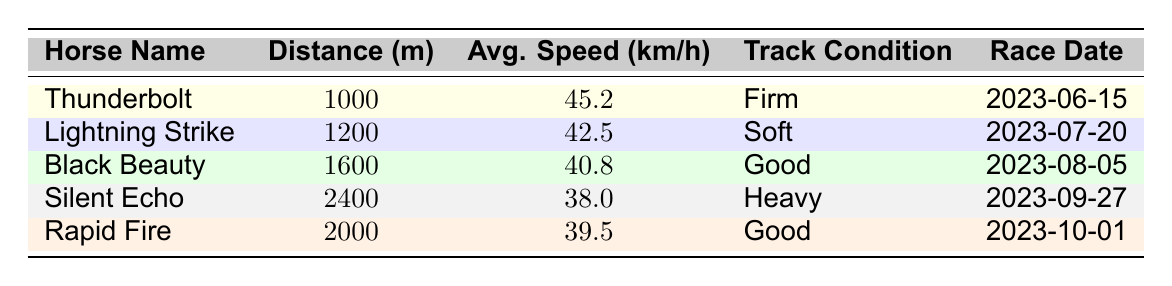What is the average speed of Thunderbolt? Looking at the table, the average speed of Thunderbolt is listed directly in the row under his name. It shows that his average speed is 45.2 km/h.
Answer: 45.2 km/h Which horse ran the longest distance and what was the average speed? The longest distance in the table is 2400 meters, which is associated with Silent Echo. The average speed for Silent Echo is displayed as 38.0 km/h.
Answer: Silent Echo, 38.0 km/h Is there a horse that ran on a heavy track? Yes, the table indicates that Silent Echo ran on a heavy track. This is evident from the track condition column where "Heavy" is specified for Silent Echo's entry.
Answer: Yes What is the difference in average speed between Lightning Strike and Rapid Fire? To find the difference, we need the average speeds: Lightning Strike has an average speed of 42.5 km/h, and Rapid Fire has 39.5 km/h. The difference is calculated as 42.5 - 39.5 = 3.0 km/h.
Answer: 3.0 km/h Which horse had the highest average speed and what is that speed? The highest average speed can be identified by comparing all average speeds in the table. Thunderbolt has the highest speed listed at 45.2 km/h.
Answer: Thunderbolt, 45.2 km/h What is the average speed of the horses that competed on good track conditions? There are two horses that ran on good track conditions: Black Beauty (40.8 km/h) and Rapid Fire (39.5 km/h). To find the average speed, we sum the speeds (40.8 + 39.5 = 80.3) and divide by 2, resulting in 80.3/2 = 40.15 km/h.
Answer: 40.15 km/h Did any horse run a distance of 2000 meters? Yes, Rapid Fire ran a distance of 2000 meters, as shown in the distance column of the corresponding row.
Answer: Yes What is the overall trend in average speed as the distance increases based on the data provided? By examining the average speeds alongside the distances, it can be noted that average speeds tend to decrease as the distances increase. For instance, Thunderbolt's speed (1000m) is the highest, and Silent Echo's (2400m) is the lowest.
Answer: Average speed decreases with increased distance 